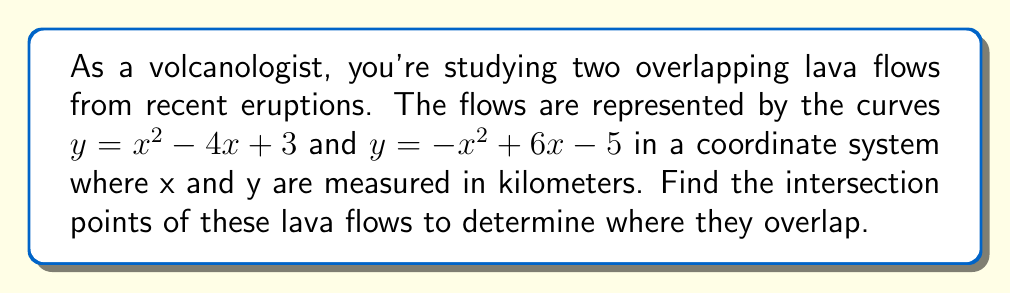Solve this math problem. To find the intersection points, we need to solve the equation where both curves are equal:

1) Set the equations equal to each other:
   $x^2 - 4x + 3 = -x^2 + 6x - 5$

2) Rearrange the equation to standard form:
   $x^2 - 4x + 3 + x^2 - 6x + 5 = 0$
   $2x^2 - 10x + 8 = 0$

3) Simplify by dividing all terms by 2:
   $x^2 - 5x + 4 = 0$

4) This is a quadratic equation. We can solve it using the quadratic formula:
   $x = \frac{-b \pm \sqrt{b^2 - 4ac}}{2a}$

   Where $a = 1$, $b = -5$, and $c = 4$

5) Substitute these values into the quadratic formula:
   $x = \frac{5 \pm \sqrt{25 - 16}}{2} = \frac{5 \pm \sqrt{9}}{2} = \frac{5 \pm 3}{2}$

6) Solve for the two x-values:
   $x_1 = \frac{5 + 3}{2} = 4$ and $x_2 = \frac{5 - 3}{2} = 1$

7) To find the y-coordinates, substitute these x-values into either of the original equations. Let's use $y = x^2 - 4x + 3$:

   For $x_1 = 4$: $y = 4^2 - 4(4) + 3 = 16 - 16 + 3 = 3$
   For $x_2 = 1$: $y = 1^2 - 4(1) + 3 = 1 - 4 + 3 = 0$

Therefore, the intersection points are (4, 3) and (1, 0).
Answer: (4, 3) and (1, 0) 